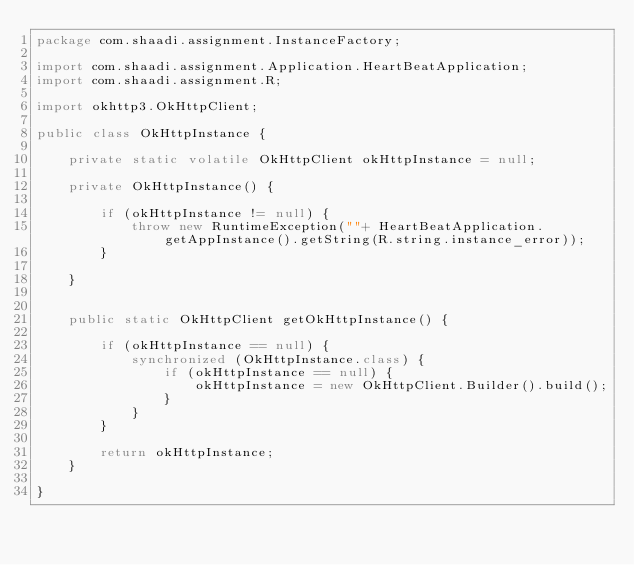Convert code to text. <code><loc_0><loc_0><loc_500><loc_500><_Java_>package com.shaadi.assignment.InstanceFactory;

import com.shaadi.assignment.Application.HeartBeatApplication;
import com.shaadi.assignment.R;

import okhttp3.OkHttpClient;

public class OkHttpInstance {

    private static volatile OkHttpClient okHttpInstance = null;

    private OkHttpInstance() {

        if (okHttpInstance != null) {
            throw new RuntimeException(""+ HeartBeatApplication.getAppInstance().getString(R.string.instance_error));
        }

    }


    public static OkHttpClient getOkHttpInstance() {

        if (okHttpInstance == null) {
            synchronized (OkHttpInstance.class) {
                if (okHttpInstance == null) {
                    okHttpInstance = new OkHttpClient.Builder().build();
                }
            }
        }

        return okHttpInstance;
    }

}
</code> 